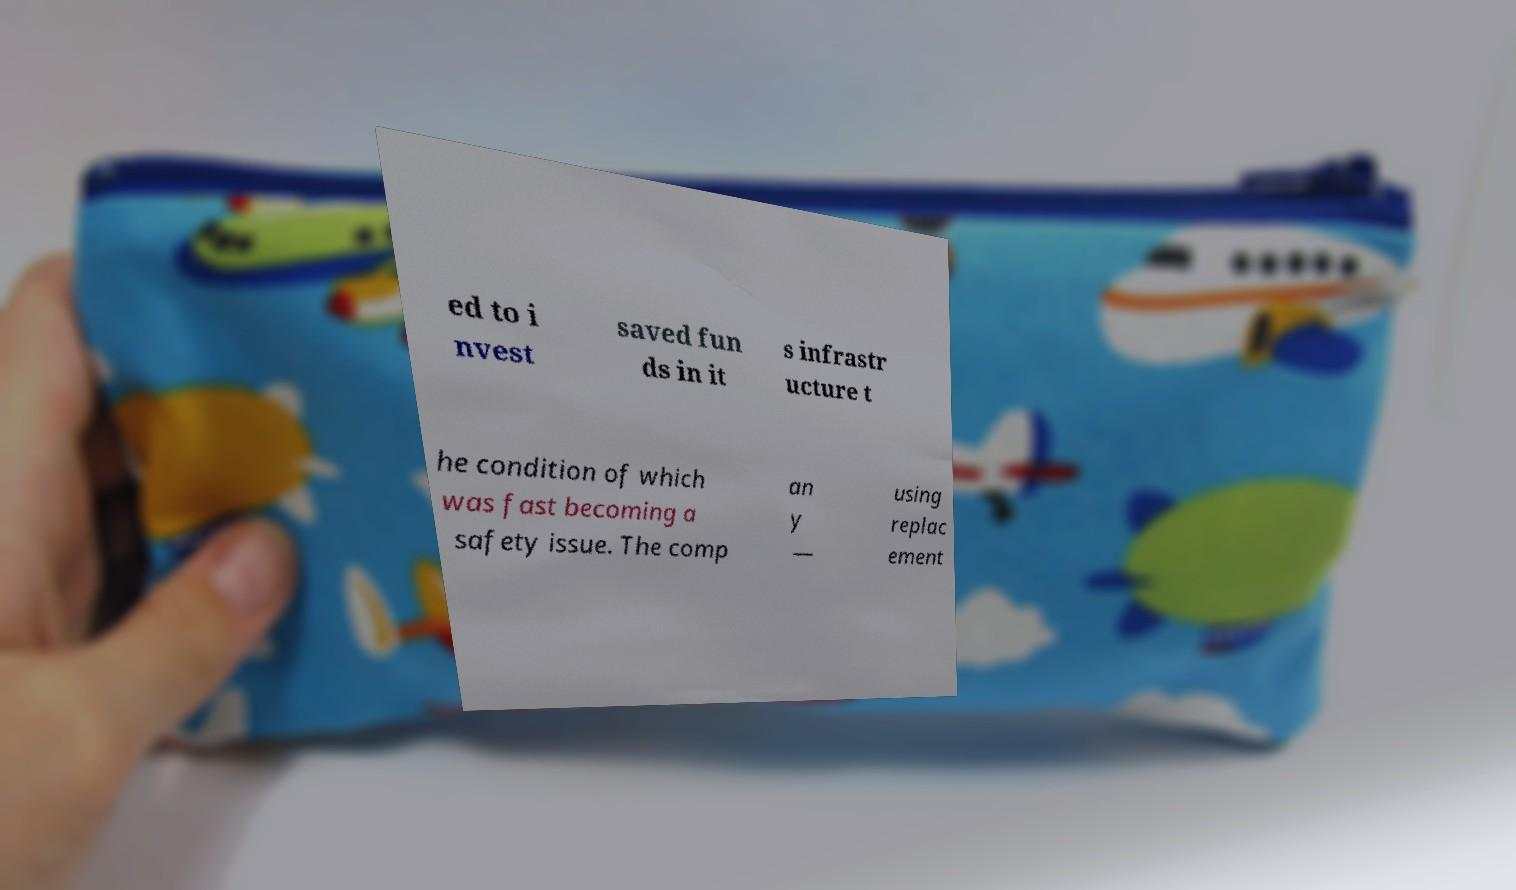Please identify and transcribe the text found in this image. ed to i nvest saved fun ds in it s infrastr ucture t he condition of which was fast becoming a safety issue. The comp an y — using replac ement 